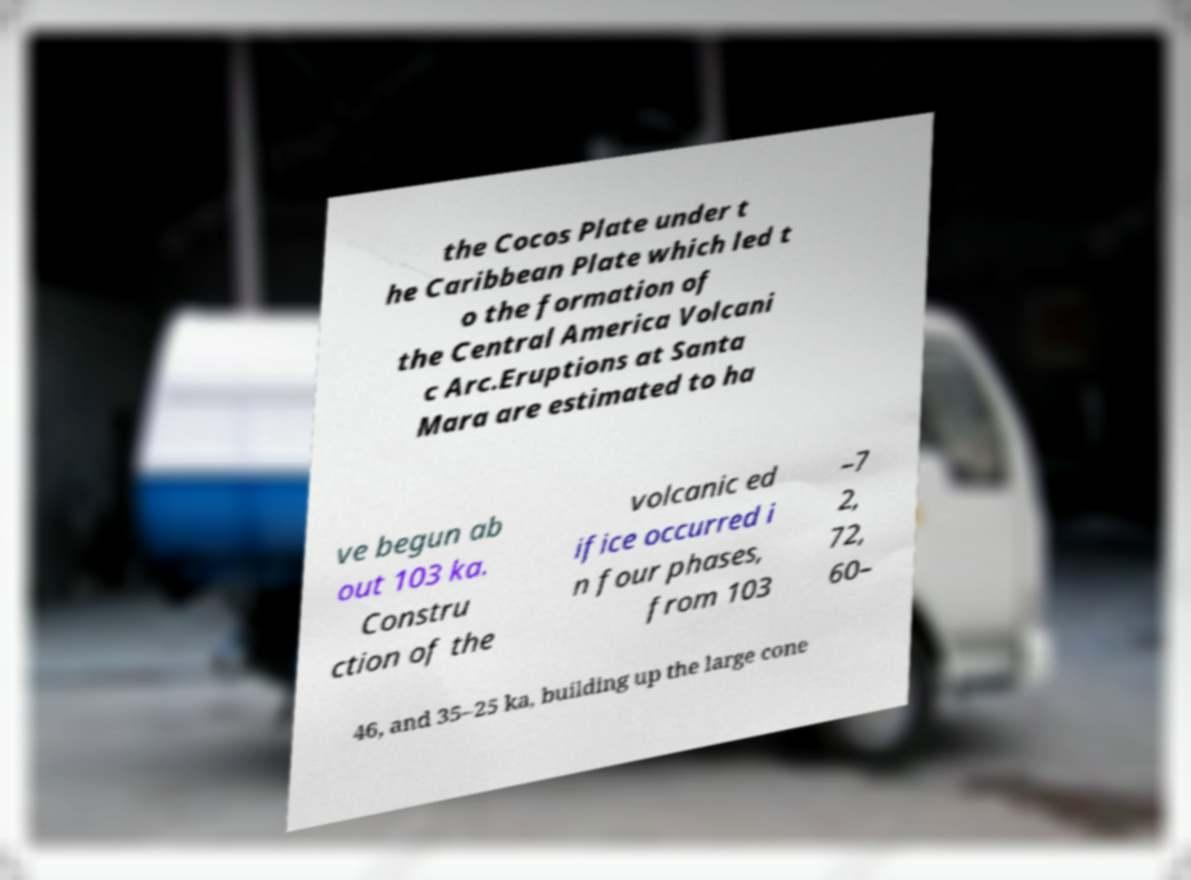What messages or text are displayed in this image? I need them in a readable, typed format. the Cocos Plate under t he Caribbean Plate which led t o the formation of the Central America Volcani c Arc.Eruptions at Santa Mara are estimated to ha ve begun ab out 103 ka. Constru ction of the volcanic ed ifice occurred i n four phases, from 103 –7 2, 72, 60– 46, and 35–25 ka, building up the large cone 